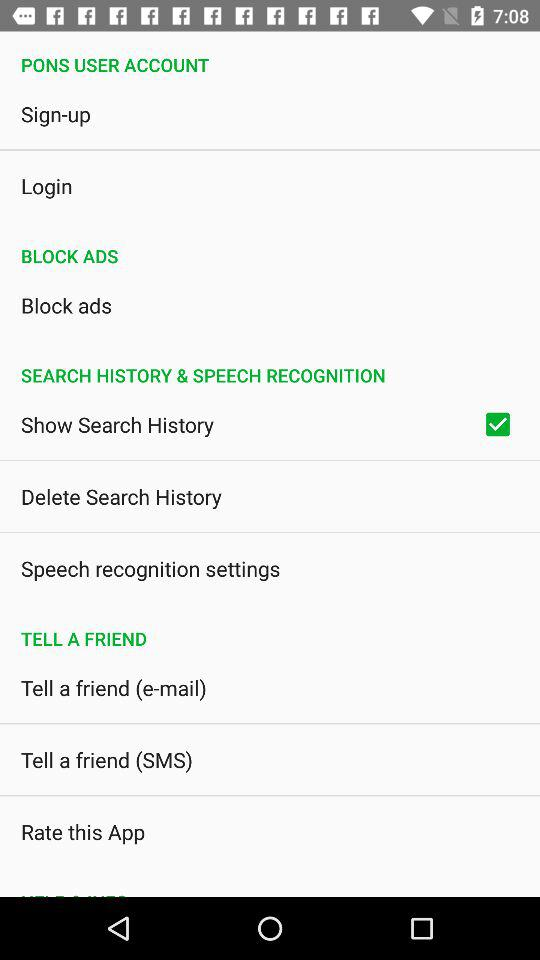How many items in the 'Search History & Speech Recognition' section have a checkbox?
Answer the question using a single word or phrase. 1 